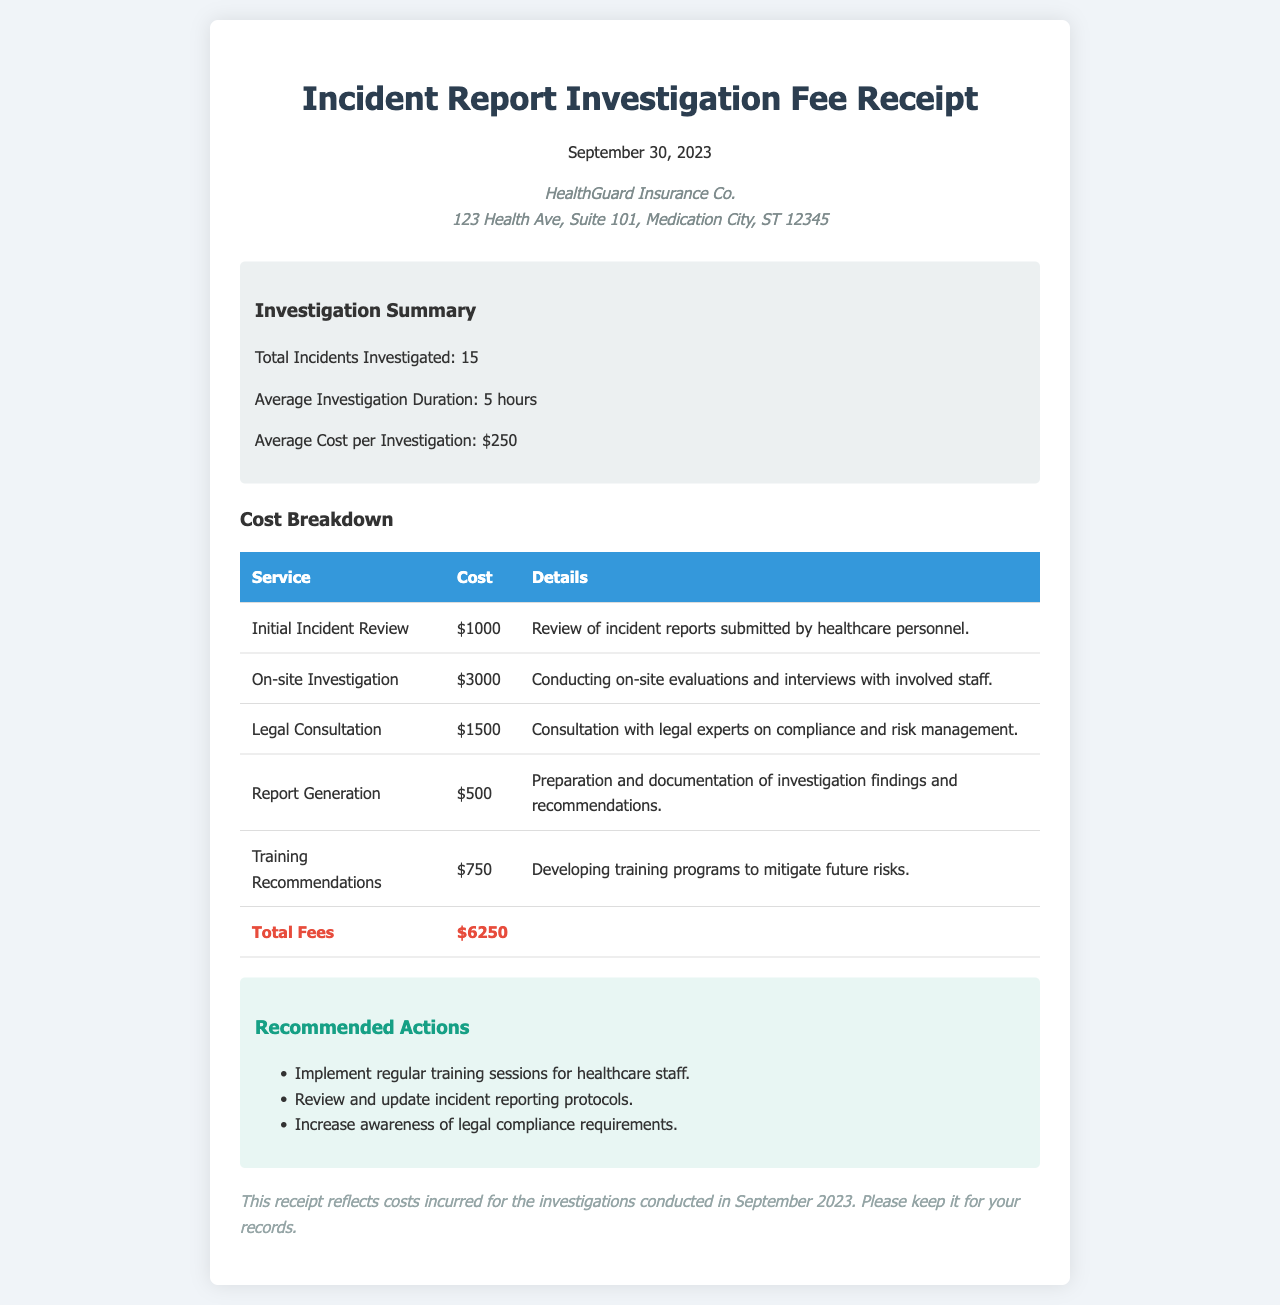What is the date of the receipt? The date of the receipt is mentioned in the document header.
Answer: September 30, 2023 How many incidents were investigated? The total number of incidents investigated is clearly stated in the investigation summary section.
Answer: 15 What is the total fee for the investigations? The total fees charged for the investigations are provided in the cost breakdown table.
Answer: $6250 What was the cost of the on-site investigation? The specific cost for the on-site investigation is listed in the cost breakdown table under service details.
Answer: $3000 What is one of the recommended actions? The recommendations section of the document lists several actions to take, and one is easily selectable.
Answer: Implement regular training sessions for healthcare staff What was the average cost per investigation? The average cost per investigation is specified in the investigation summary section.
Answer: $250 What type of consultation was included in the costs? The document provides details about various services, including a specific legal service.
Answer: Legal Consultation What is the average investigation duration? The average investigation duration is a part of the investigation summary.
Answer: 5 hours 